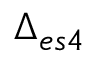<formula> <loc_0><loc_0><loc_500><loc_500>\Delta _ { e s 4 }</formula> 